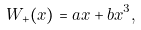Convert formula to latex. <formula><loc_0><loc_0><loc_500><loc_500>W _ { + } ( x ) = a x + b x ^ { 3 } ,</formula> 